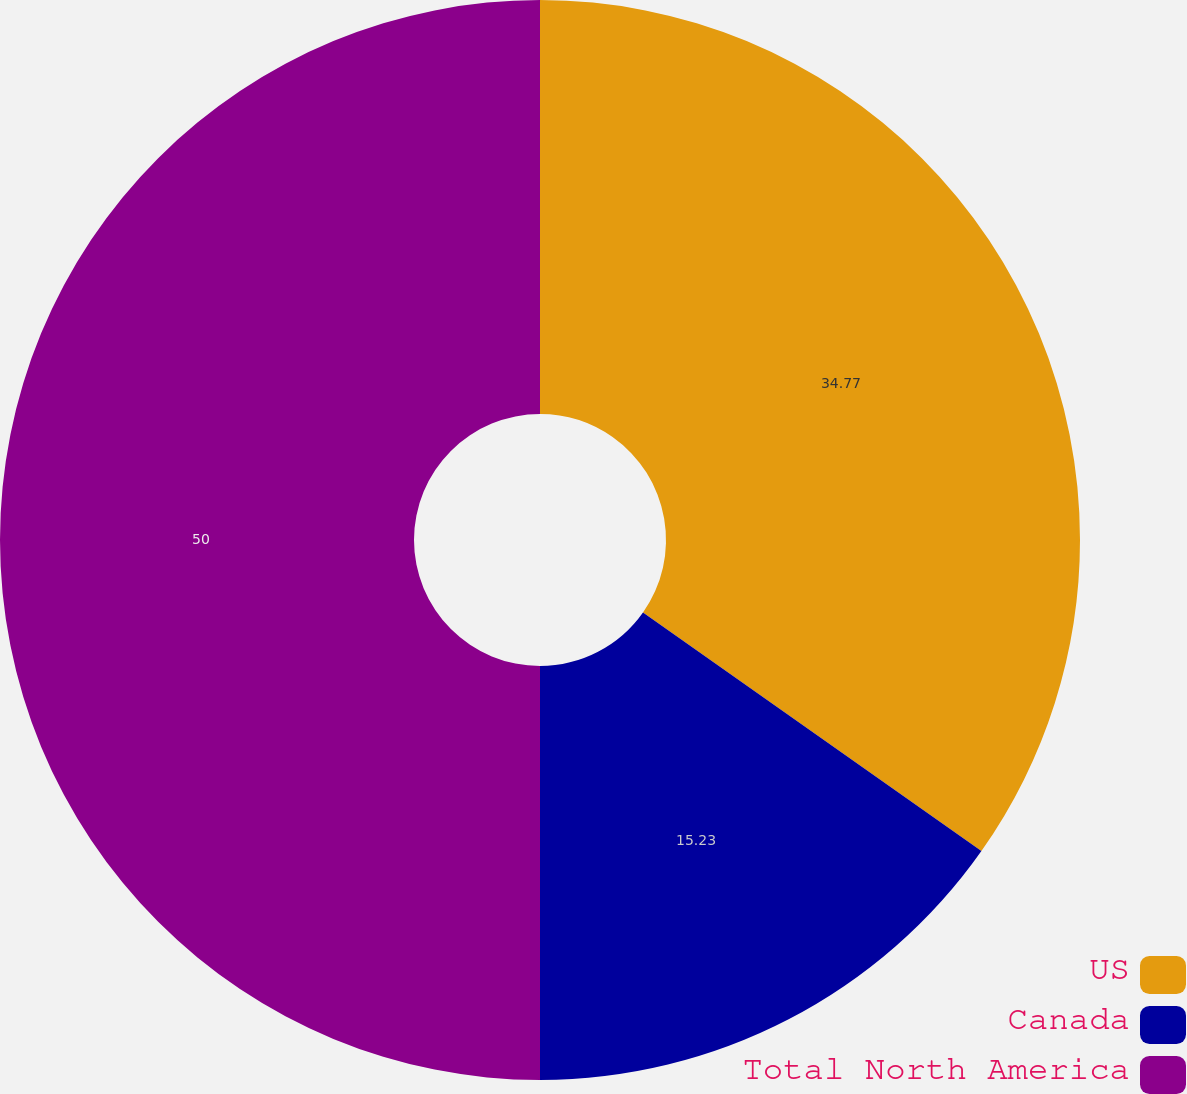Convert chart. <chart><loc_0><loc_0><loc_500><loc_500><pie_chart><fcel>US<fcel>Canada<fcel>Total North America<nl><fcel>34.77%<fcel>15.23%<fcel>50.0%<nl></chart> 